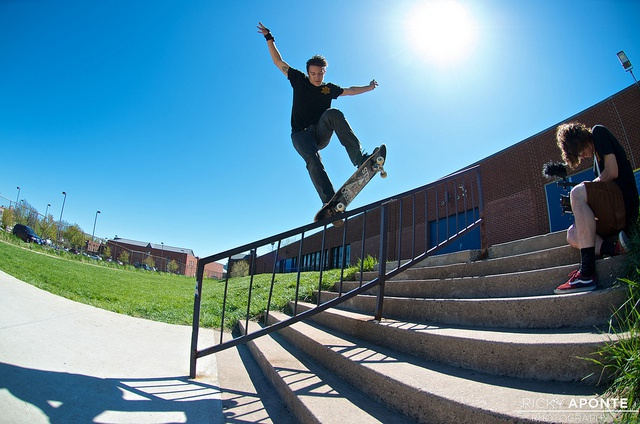Describe the objects in this image and their specific colors. I can see people in blue, black, gray, navy, and maroon tones, people in blue, black, gray, and navy tones, skateboard in blue, black, gray, and darkgray tones, car in blue, black, and navy tones, and car in blue, navy, black, and gray tones in this image. 